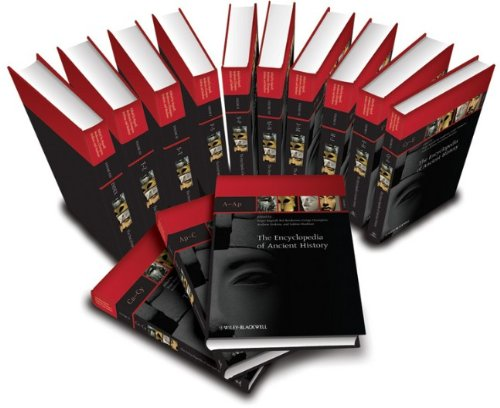Is this book related to Science & Math? No, this book is not related to Science & Math. Its primary focus is on historical subjects and ancient civilizations, providing insights into their societies, cultures, and developments. 